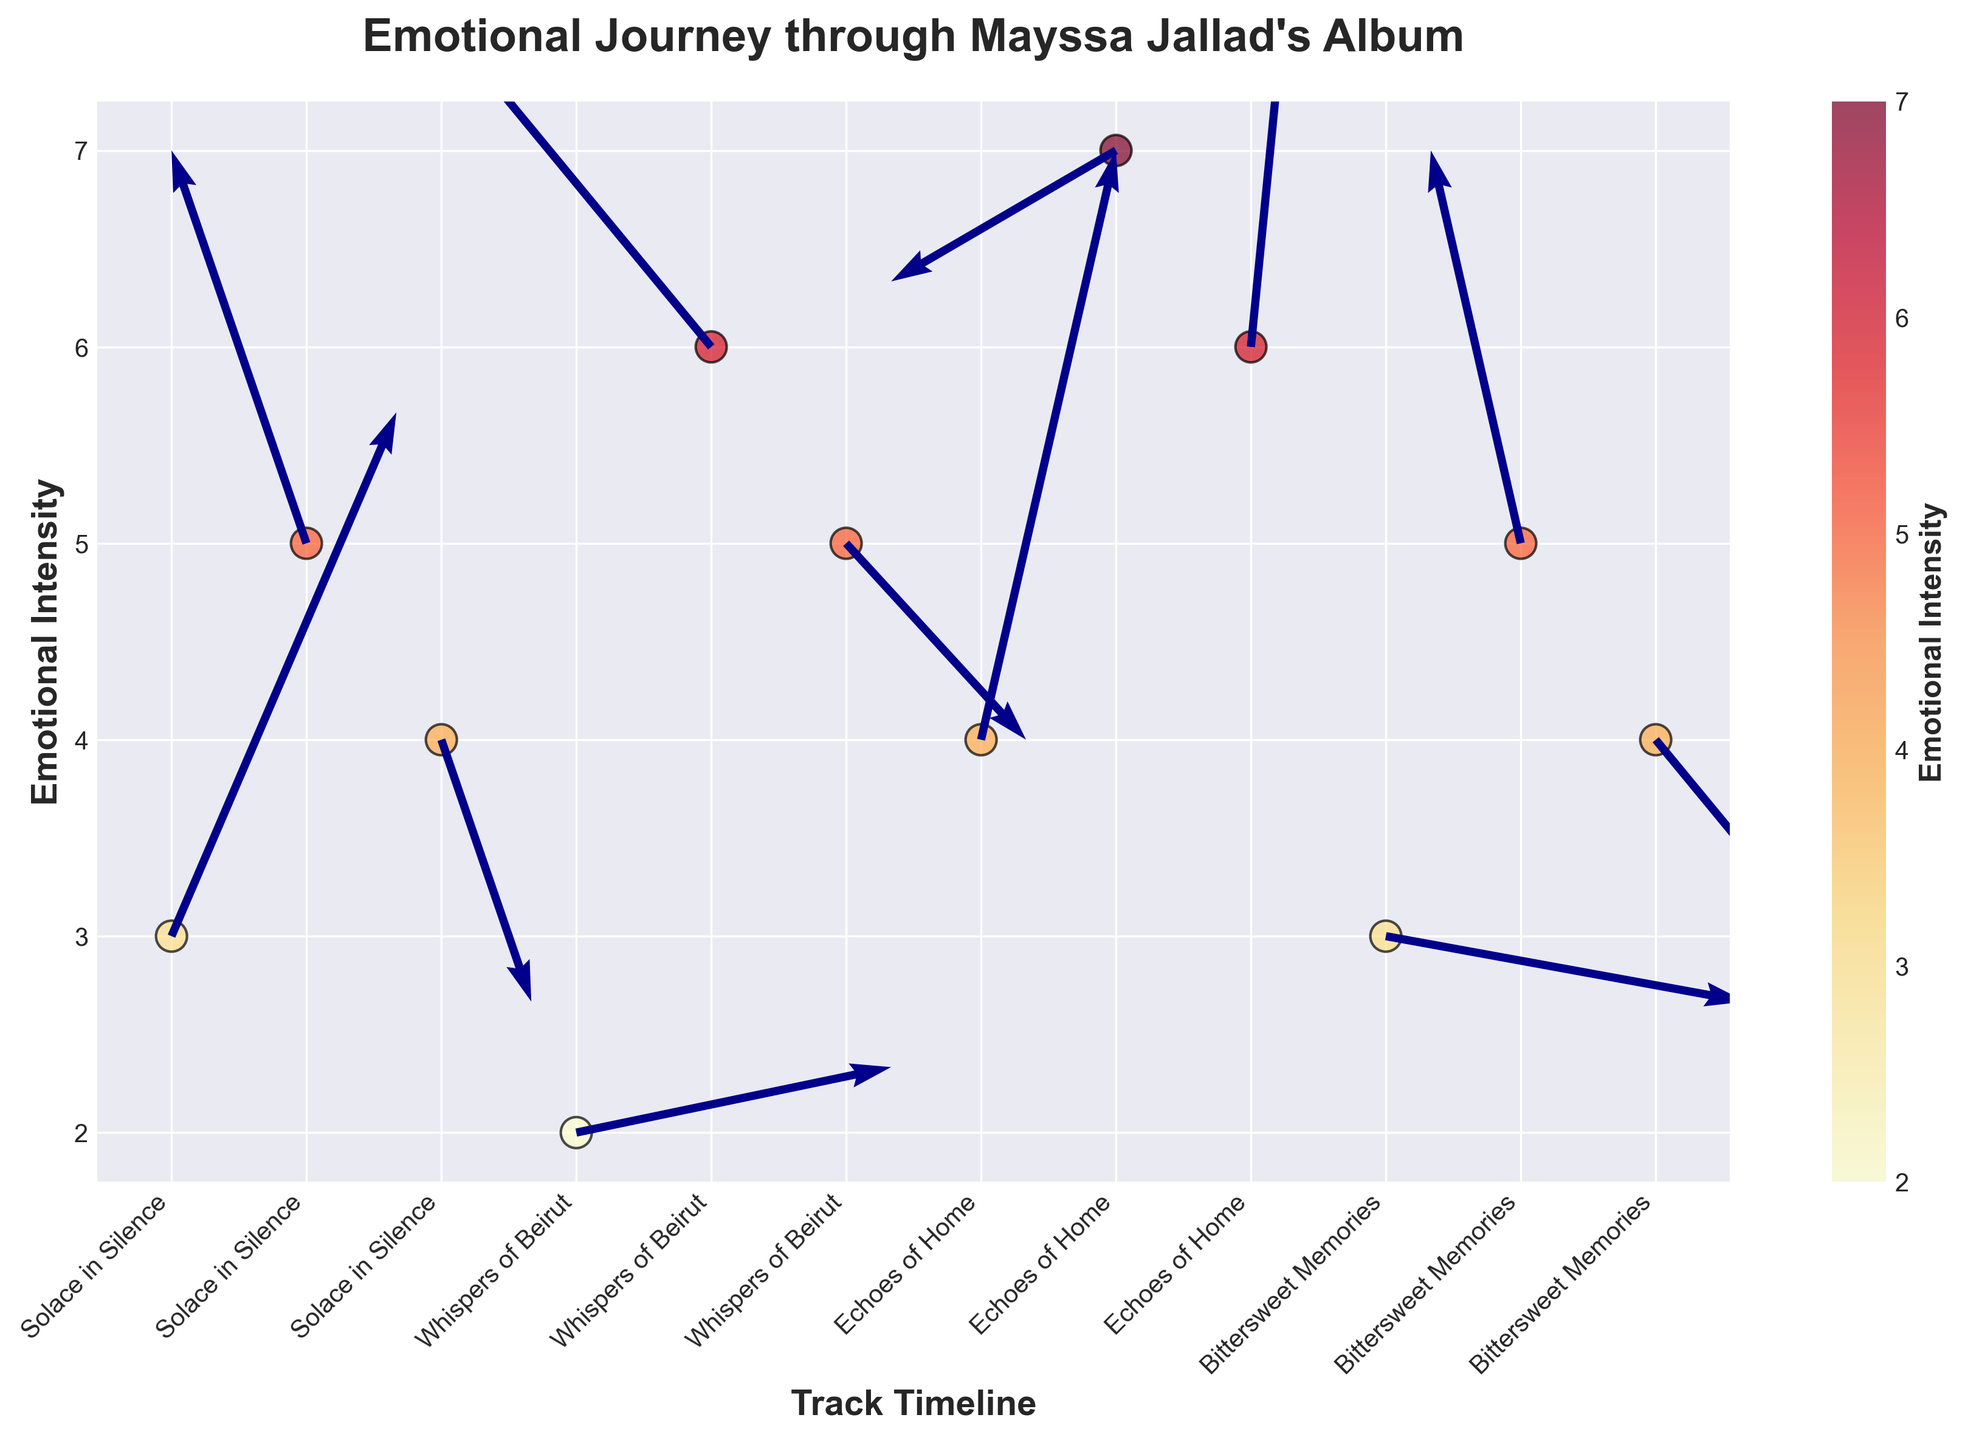What is the title of the plot? The title is typically displayed at the top of the plot. In this case, it is written explicitly as the "Emotional Journey through Mayssa Jallad's Album".
Answer: Emotional Journey through Mayssa Jallad's Album How many tracks are represented in the plot? Each unique label on the x-axis represents a different track. Counting these labels will give the number of tracks.
Answer: 4 What is the highest emotional intensity observed for "Whispers of Beirut"? Look at the emotional intensity values plotted for "Whispers of Beirut" and identify the highest one. In this case, it's the highest y-value among the "Whispers of Beirut" data points.
Answer: 6 Which track shows the most significant change in direction (X, Y) at any given point? Examine the quiver vectors' lengths for each track. The length represents the magnitude of direction change, calculated using the formula √(X^2 + Y^2). "Echoes of Home" at 0:45 has the greatest visual length.
Answer: Echoes of Home What is the average emotional intensity of all tracks combined? Sum all the emotional intensity values and divide by the number of data points to find the average. The data points and their values are: 3, 5, 4, 2, 6, 5, 4, 7, 6, 3, 5, 4. Thus, the average is (3+5+4+2+6+5+4+7+6+3+5+4)/12.
Answer: 4.58 Which track demonstrates the highest emotional intensity change from one point to another? Compare the differences in emotional intensity values between consecutive points within each track, and identify the track with the highest value change. For example, within "Echoes of Home", it changes from 4 to 7. Calculate differences for each track and find the maximum change.
Answer: Whispers of Beirut Is there any track where the emotional intensity decreases at any time? Look for any drops in the y-values for each track. Check if the emotional intensity value at a later time is less than an earlier time for a given track. "Solace in Silence" drops from 5 to 4.
Answer: Yes Which data point has the maximum vector length, and what are the direction change values (X, Y) at that point? Calculate the vector length (using √(X^2 + Y^2)) for each data point. The largest vector length corresponds to the maximum direction change. For instance, check each vector's length and find the maximum.
Answer: Echoes of Home, 0:45, (0.3, 0.9) What is the range of emotional intensity for "Bittersweet Memories"? Subtract the lowest emotional intensity value from the highest within "Bittersweet Memories". The values are 3, 5, and 4, so the range is 5 - 3.
Answer: 2 